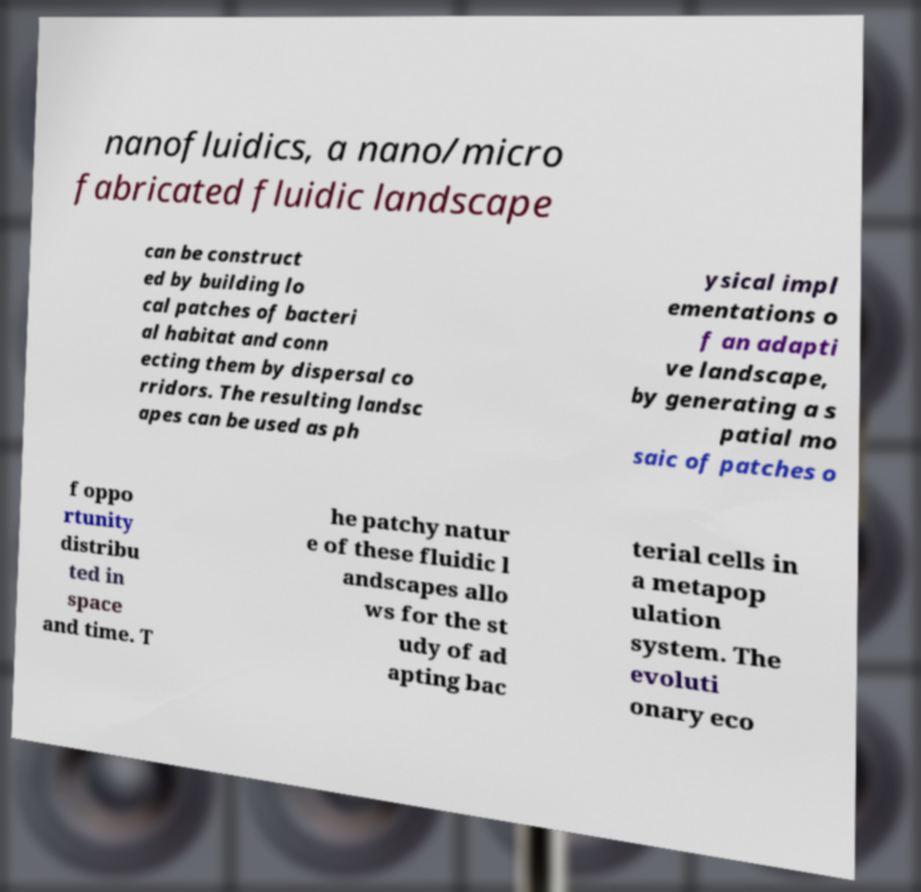There's text embedded in this image that I need extracted. Can you transcribe it verbatim? nanofluidics, a nano/micro fabricated fluidic landscape can be construct ed by building lo cal patches of bacteri al habitat and conn ecting them by dispersal co rridors. The resulting landsc apes can be used as ph ysical impl ementations o f an adapti ve landscape, by generating a s patial mo saic of patches o f oppo rtunity distribu ted in space and time. T he patchy natur e of these fluidic l andscapes allo ws for the st udy of ad apting bac terial cells in a metapop ulation system. The evoluti onary eco 